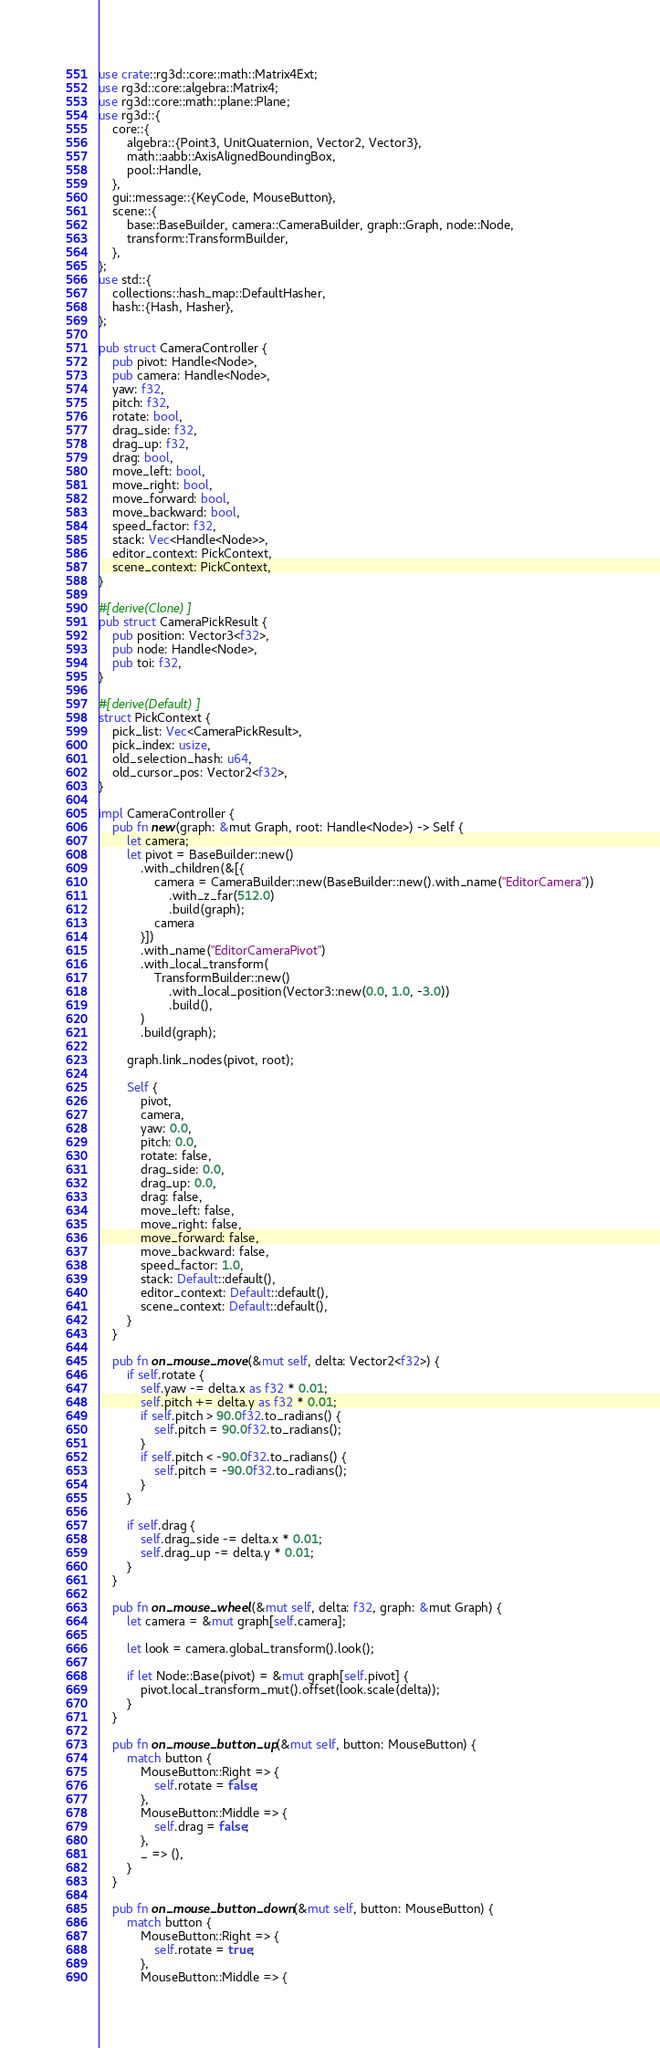Convert code to text. <code><loc_0><loc_0><loc_500><loc_500><_Rust_>use crate::rg3d::core::math::Matrix4Ext;
use rg3d::core::algebra::Matrix4;
use rg3d::core::math::plane::Plane;
use rg3d::{
    core::{
        algebra::{Point3, UnitQuaternion, Vector2, Vector3},
        math::aabb::AxisAlignedBoundingBox,
        pool::Handle,
    },
    gui::message::{KeyCode, MouseButton},
    scene::{
        base::BaseBuilder, camera::CameraBuilder, graph::Graph, node::Node,
        transform::TransformBuilder,
    },
};
use std::{
    collections::hash_map::DefaultHasher,
    hash::{Hash, Hasher},
};

pub struct CameraController {
    pub pivot: Handle<Node>,
    pub camera: Handle<Node>,
    yaw: f32,
    pitch: f32,
    rotate: bool,
    drag_side: f32,
    drag_up: f32,
    drag: bool,
    move_left: bool,
    move_right: bool,
    move_forward: bool,
    move_backward: bool,
    speed_factor: f32,
    stack: Vec<Handle<Node>>,
    editor_context: PickContext,
    scene_context: PickContext,
}

#[derive(Clone)]
pub struct CameraPickResult {
    pub position: Vector3<f32>,
    pub node: Handle<Node>,
    pub toi: f32,
}

#[derive(Default)]
struct PickContext {
    pick_list: Vec<CameraPickResult>,
    pick_index: usize,
    old_selection_hash: u64,
    old_cursor_pos: Vector2<f32>,
}

impl CameraController {
    pub fn new(graph: &mut Graph, root: Handle<Node>) -> Self {
        let camera;
        let pivot = BaseBuilder::new()
            .with_children(&[{
                camera = CameraBuilder::new(BaseBuilder::new().with_name("EditorCamera"))
                    .with_z_far(512.0)
                    .build(graph);
                camera
            }])
            .with_name("EditorCameraPivot")
            .with_local_transform(
                TransformBuilder::new()
                    .with_local_position(Vector3::new(0.0, 1.0, -3.0))
                    .build(),
            )
            .build(graph);

        graph.link_nodes(pivot, root);

        Self {
            pivot,
            camera,
            yaw: 0.0,
            pitch: 0.0,
            rotate: false,
            drag_side: 0.0,
            drag_up: 0.0,
            drag: false,
            move_left: false,
            move_right: false,
            move_forward: false,
            move_backward: false,
            speed_factor: 1.0,
            stack: Default::default(),
            editor_context: Default::default(),
            scene_context: Default::default(),
        }
    }

    pub fn on_mouse_move(&mut self, delta: Vector2<f32>) {
        if self.rotate {
            self.yaw -= delta.x as f32 * 0.01;
            self.pitch += delta.y as f32 * 0.01;
            if self.pitch > 90.0f32.to_radians() {
                self.pitch = 90.0f32.to_radians();
            }
            if self.pitch < -90.0f32.to_radians() {
                self.pitch = -90.0f32.to_radians();
            }
        }

        if self.drag {
            self.drag_side -= delta.x * 0.01;
            self.drag_up -= delta.y * 0.01;
        }
    }

    pub fn on_mouse_wheel(&mut self, delta: f32, graph: &mut Graph) {
        let camera = &mut graph[self.camera];

        let look = camera.global_transform().look();

        if let Node::Base(pivot) = &mut graph[self.pivot] {
            pivot.local_transform_mut().offset(look.scale(delta));
        }
    }

    pub fn on_mouse_button_up(&mut self, button: MouseButton) {
        match button {
            MouseButton::Right => {
                self.rotate = false;
            },
            MouseButton::Middle => {
                self.drag = false;
            },
            _ => (),
        }
    }

    pub fn on_mouse_button_down(&mut self, button: MouseButton) {
        match button {
            MouseButton::Right => {
                self.rotate = true;
            },
            MouseButton::Middle => {</code> 